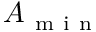<formula> <loc_0><loc_0><loc_500><loc_500>A _ { m i n }</formula> 